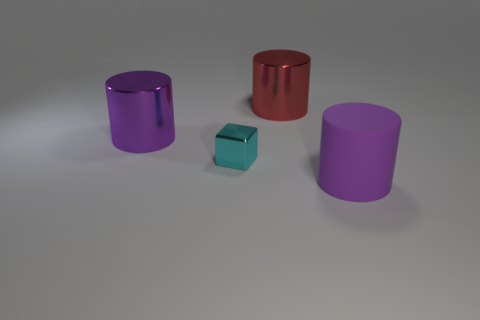Add 2 cyan cubes. How many objects exist? 6 Subtract all blocks. How many objects are left? 3 Add 4 shiny blocks. How many shiny blocks exist? 5 Subtract 0 red blocks. How many objects are left? 4 Subtract all cyan blocks. Subtract all cyan metallic cubes. How many objects are left? 2 Add 2 large red metal objects. How many large red metal objects are left? 3 